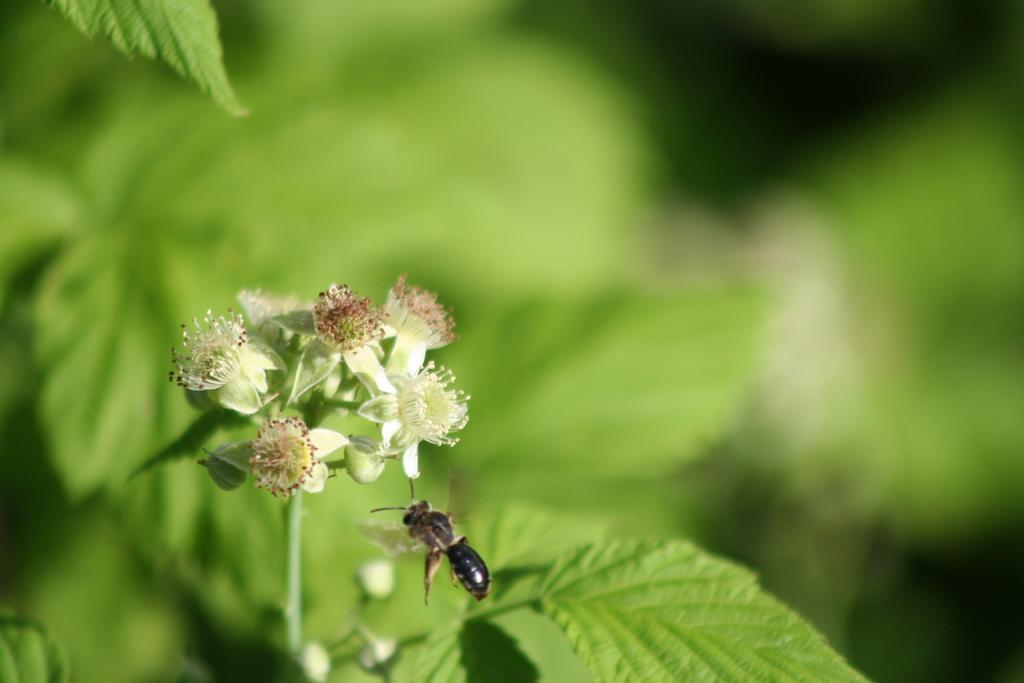What type of plant is visible in the image? There is a plant with flowers in the image. What can be seen interacting with the plant in the image? There is a honey bee in the image. What type of parent is shown taking care of the honey bee in the image? There is no parent present in the image, nor is there any indication of a honey bee being taken care of. 